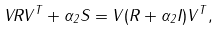<formula> <loc_0><loc_0><loc_500><loc_500>V R V ^ { T } + \alpha _ { 2 } S = V ( R + \alpha _ { 2 } I ) V ^ { T } ,</formula> 